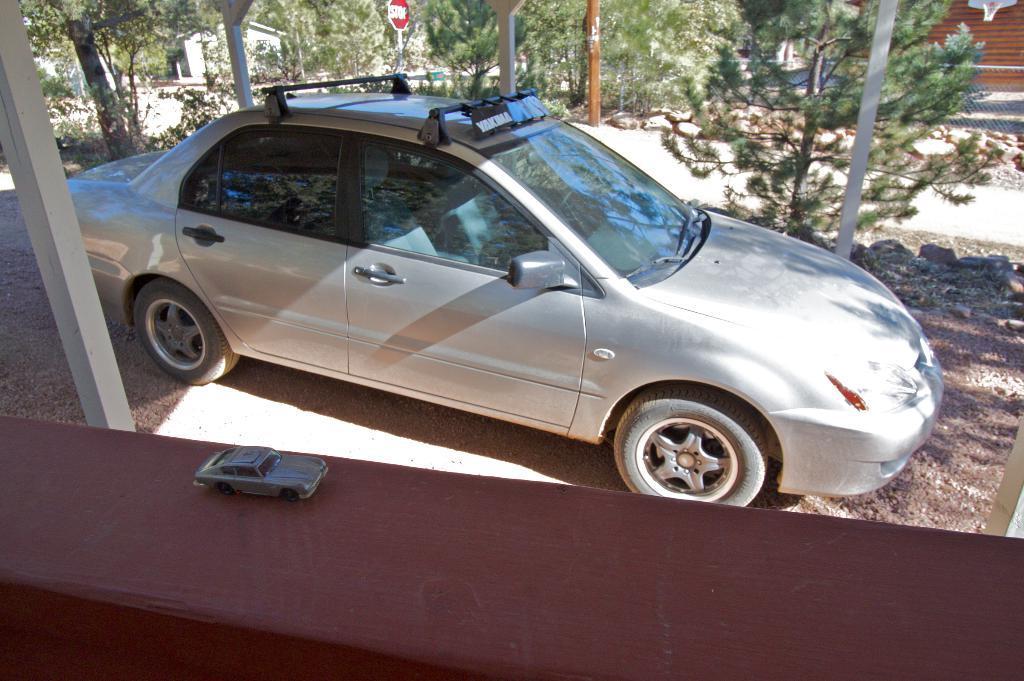How would you summarize this image in a sentence or two? At the bottom of the image on the wall there is a toy car. Behind the wall there is a car. Behind the car there are poles with sign boards and also there are trees. Behind the trees there are houses. 